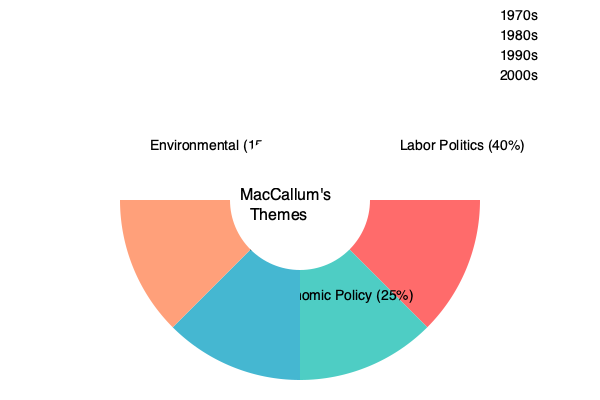Based on the pie chart depicting Mungo MacCallum's political commentary themes across decades, which theme shows the most significant shift in focus from the 1970s to the 2000s, and what does this reveal about the evolution of Australian political discourse during this period? To answer this question, we need to analyze the changes in MacCallum's themes over the decades:

1. 1970s: Labor Politics dominates with 40% of the commentary.
2. 1980s: Economic Policy emerges as a significant theme at 25%.
3. 1990s: Social Issues gain prominence with 20%.
4. 2000s: Environmental topics appear, taking up 15% of the commentary.

The most significant shift is from Labor Politics (40% in the 1970s) to the emergence of Environmental issues (15% in the 2000s). This shift reveals:

1. A diversification of political discourse in Australia over three decades.
2. The declining dominance of traditional Labor politics as the primary focus.
3. The rise of environmental concerns as a major political issue by the 2000s.

This evolution reflects:
- The changing priorities of Australian society and politics.
- The impact of global environmental awareness on domestic political discourse.
- MacCallum's adaptability in covering emerging political trends and issues.

The shift from Labor-centric commentary to a more diverse range of topics, including the environment, indicates a broadening of the Australian political landscape and the issues considered crucial for public debate.
Answer: Shift from Labor Politics to Environmental issues, reflecting diversification of Australian political discourse and rising environmental concerns. 